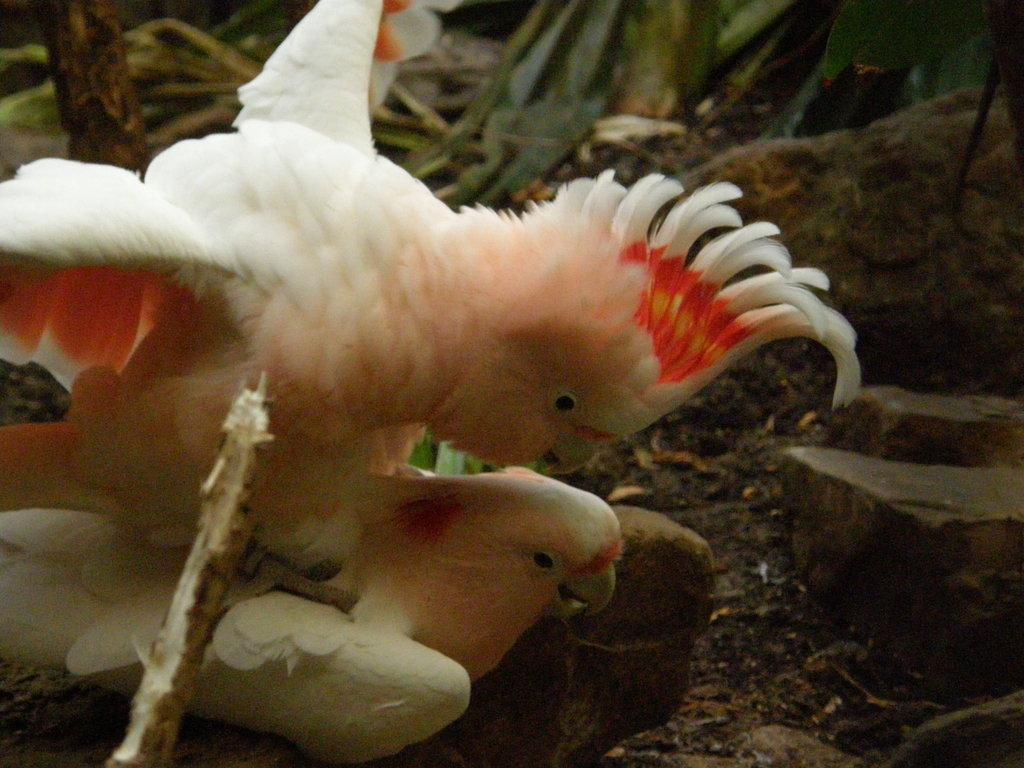What type of animals can be seen in the image? Birds can be seen in the image. What type of verse is being recited by the birds in the image? There is no indication in the image that the birds are reciting any verse, as birds do not have the ability to speak or recite poetry. 